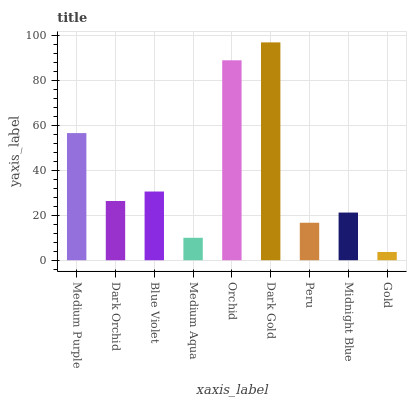Is Gold the minimum?
Answer yes or no. Yes. Is Dark Gold the maximum?
Answer yes or no. Yes. Is Dark Orchid the minimum?
Answer yes or no. No. Is Dark Orchid the maximum?
Answer yes or no. No. Is Medium Purple greater than Dark Orchid?
Answer yes or no. Yes. Is Dark Orchid less than Medium Purple?
Answer yes or no. Yes. Is Dark Orchid greater than Medium Purple?
Answer yes or no. No. Is Medium Purple less than Dark Orchid?
Answer yes or no. No. Is Dark Orchid the high median?
Answer yes or no. Yes. Is Dark Orchid the low median?
Answer yes or no. Yes. Is Peru the high median?
Answer yes or no. No. Is Blue Violet the low median?
Answer yes or no. No. 